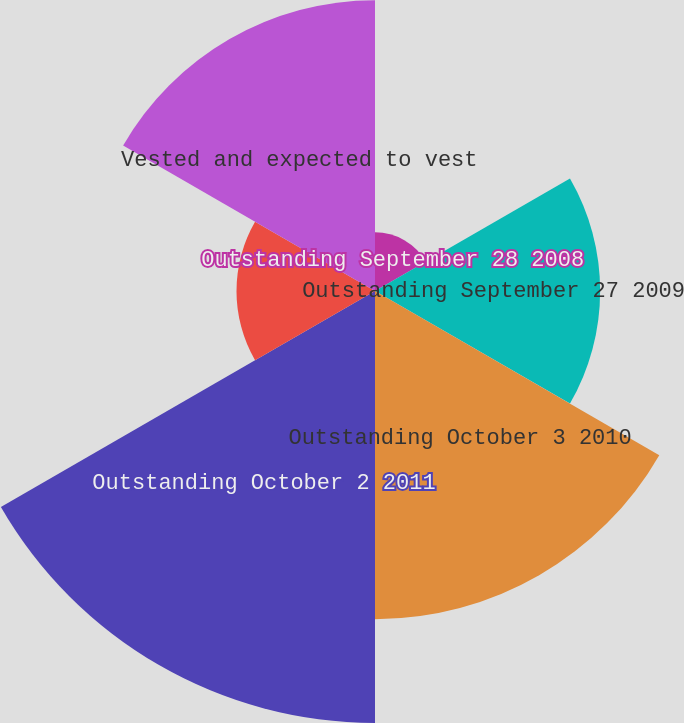Convert chart to OTSL. <chart><loc_0><loc_0><loc_500><loc_500><pie_chart><fcel>Outstanding September 28 2008<fcel>Outstanding September 27 2009<fcel>Outstanding October 3 2010<fcel>Outstanding October 2 2011<fcel>Exercisable October 2 2011<fcel>Vested and expected to vest<nl><fcel>3.98%<fcel>15.28%<fcel>22.28%<fcel>29.32%<fcel>9.4%<fcel>19.74%<nl></chart> 